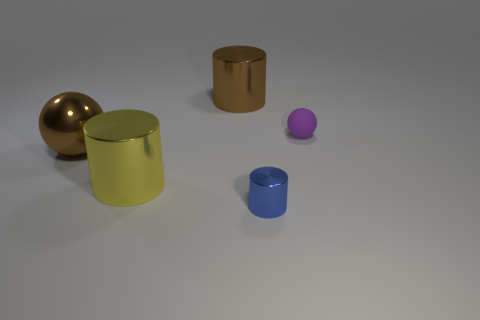Add 3 big balls. How many objects exist? 8 Subtract all cylinders. How many objects are left? 2 Subtract 0 gray cylinders. How many objects are left? 5 Subtract all cyan balls. Subtract all purple matte spheres. How many objects are left? 4 Add 1 shiny things. How many shiny things are left? 5 Add 4 purple rubber balls. How many purple rubber balls exist? 5 